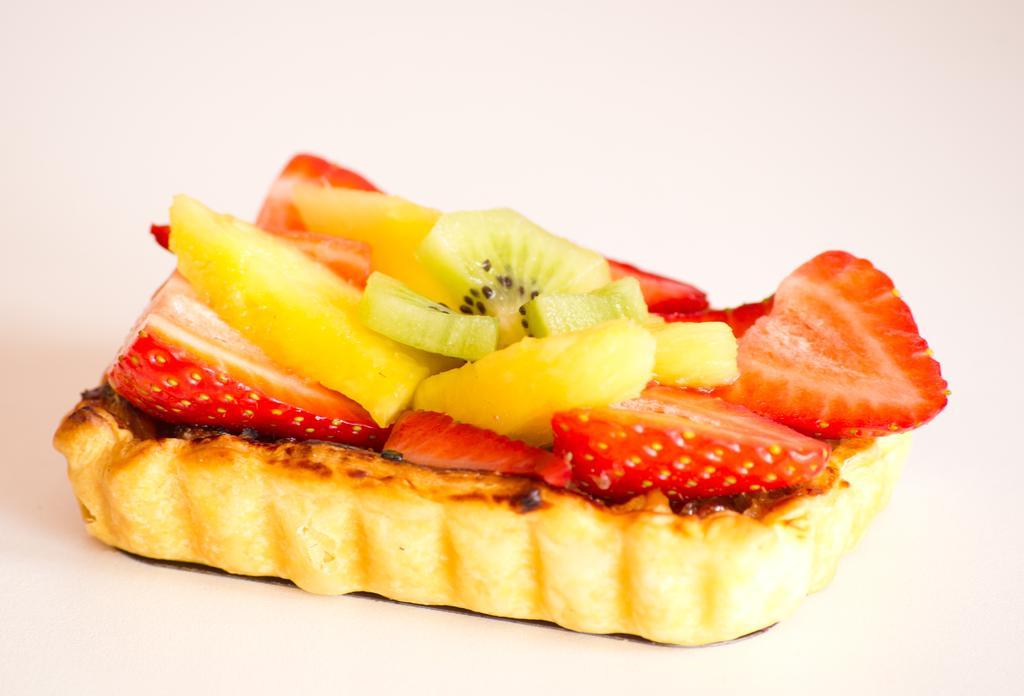Could you give a brief overview of what you see in this image? There is baked item in the center of the image, which contains slices of strawberry, kiwi and other fruit. 